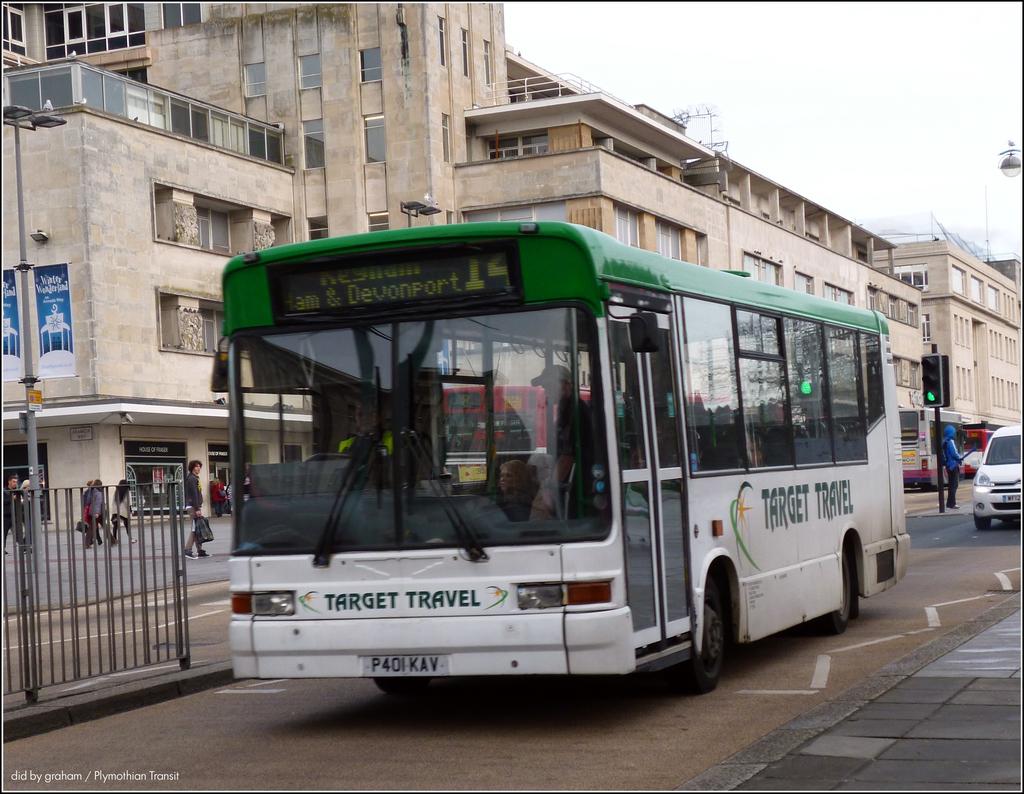What is the license number of the bus?
Offer a terse response. P401kav. 